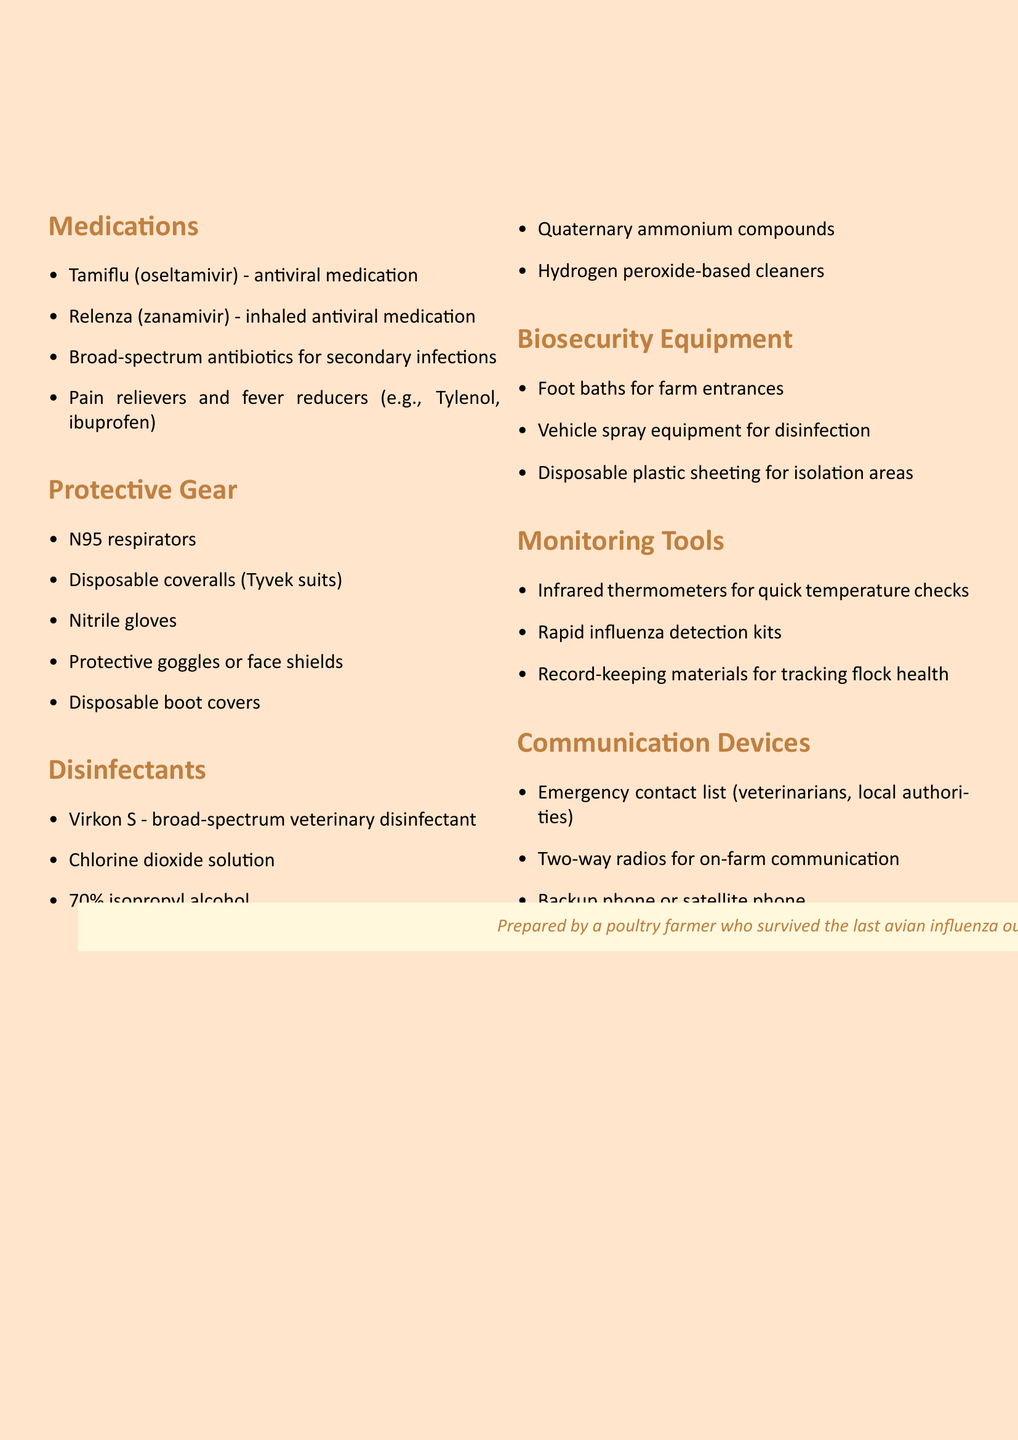What medications are listed for emergencies? The document lists various medications categorized for emergencies, including antiviral and antibiotic options.
Answer: Tamiflu (oseltamivir), Relenza (zanamivir), Broad-spectrum antibiotics, Pain relievers and fever reducers How many categories of emergency supplies are mentioned? The document divides emergency supplies into distinct categories, counting each one listed.
Answer: Six What type of respirators are included in the protective gear? The document specifies the type of respirators required for protection during outbreaks.
Answer: N95 respirators Which disinfectants are included in the inventory? The inventory details various disinfectants that can be used in an outbreak scenario.
Answer: Virkon S, Chlorine dioxide solution, 70% isopropyl alcohol, Quaternary ammonium compounds, Hydrogen peroxide-based cleaners What type of communication device is mentioned for on-farm use? The document identifies a specific tool that will help with communication during emergencies on the farm.
Answer: Two-way radios 